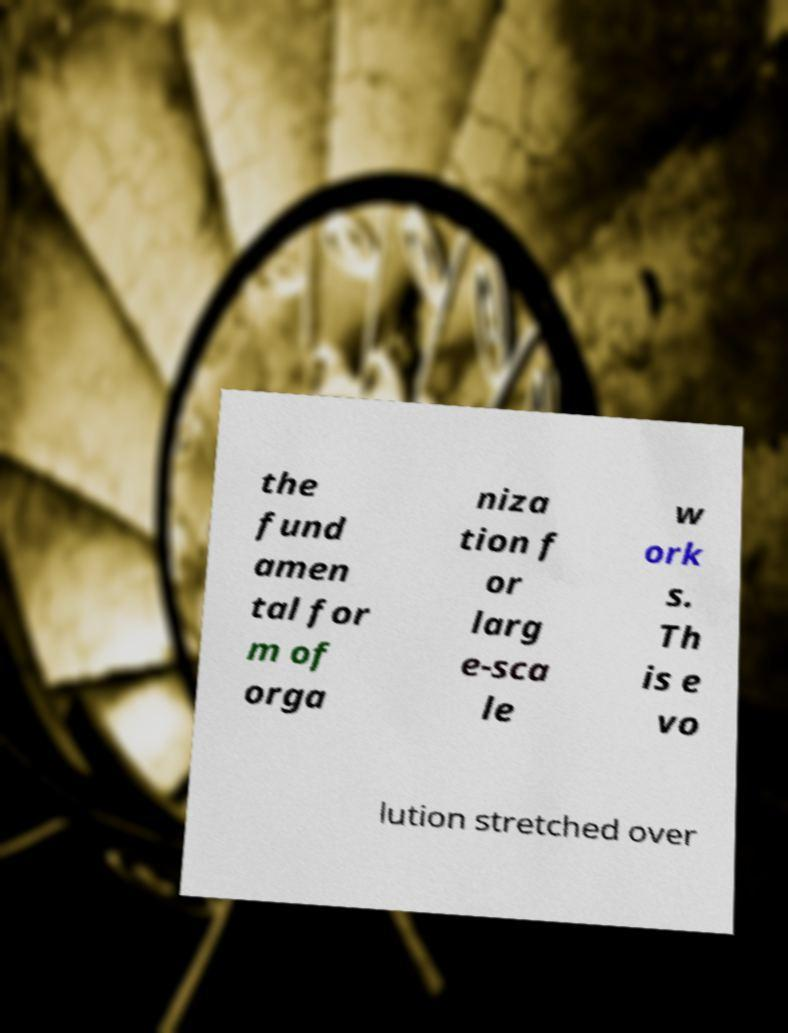Please identify and transcribe the text found in this image. the fund amen tal for m of orga niza tion f or larg e-sca le w ork s. Th is e vo lution stretched over 